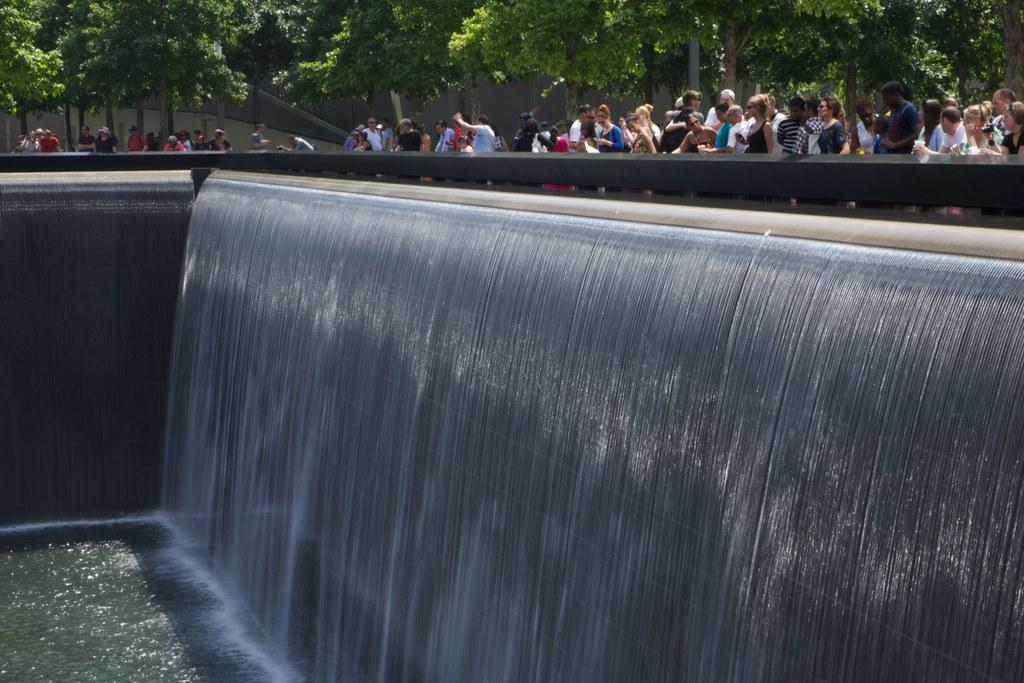What is the main feature in the center of the image? There is a fountain in the center of the image. What can be seen at the bottom of the image? There is water at the bottom of the image. What type of vegetation is visible in the background of the image? There are trees in the background of the image. Can you describe the people in the background of the image? There are people in the background of the image. What type of vest is the fountain wearing in the image? The fountain is not wearing a vest, as it is an inanimate object and not capable of wearing clothing. 